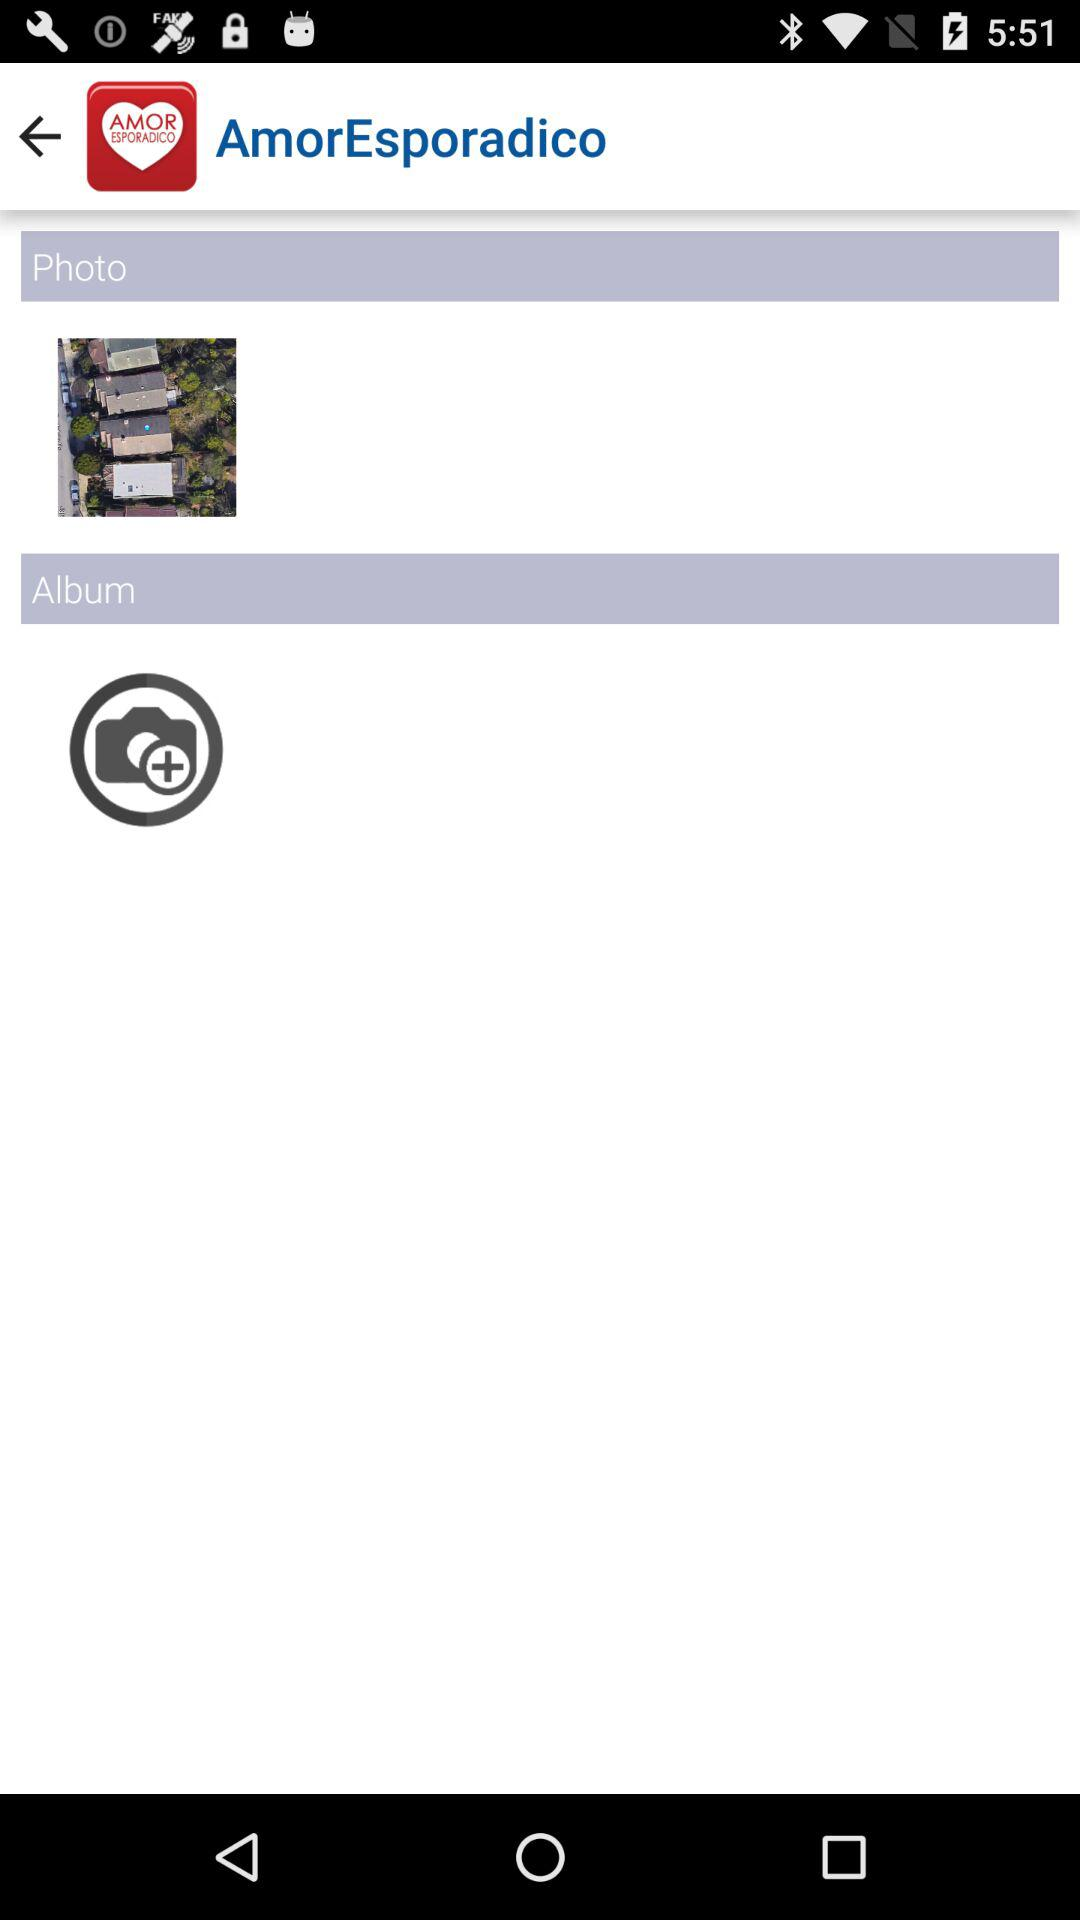What is the name of the application? The name of the application is "AmorEsporadico". 